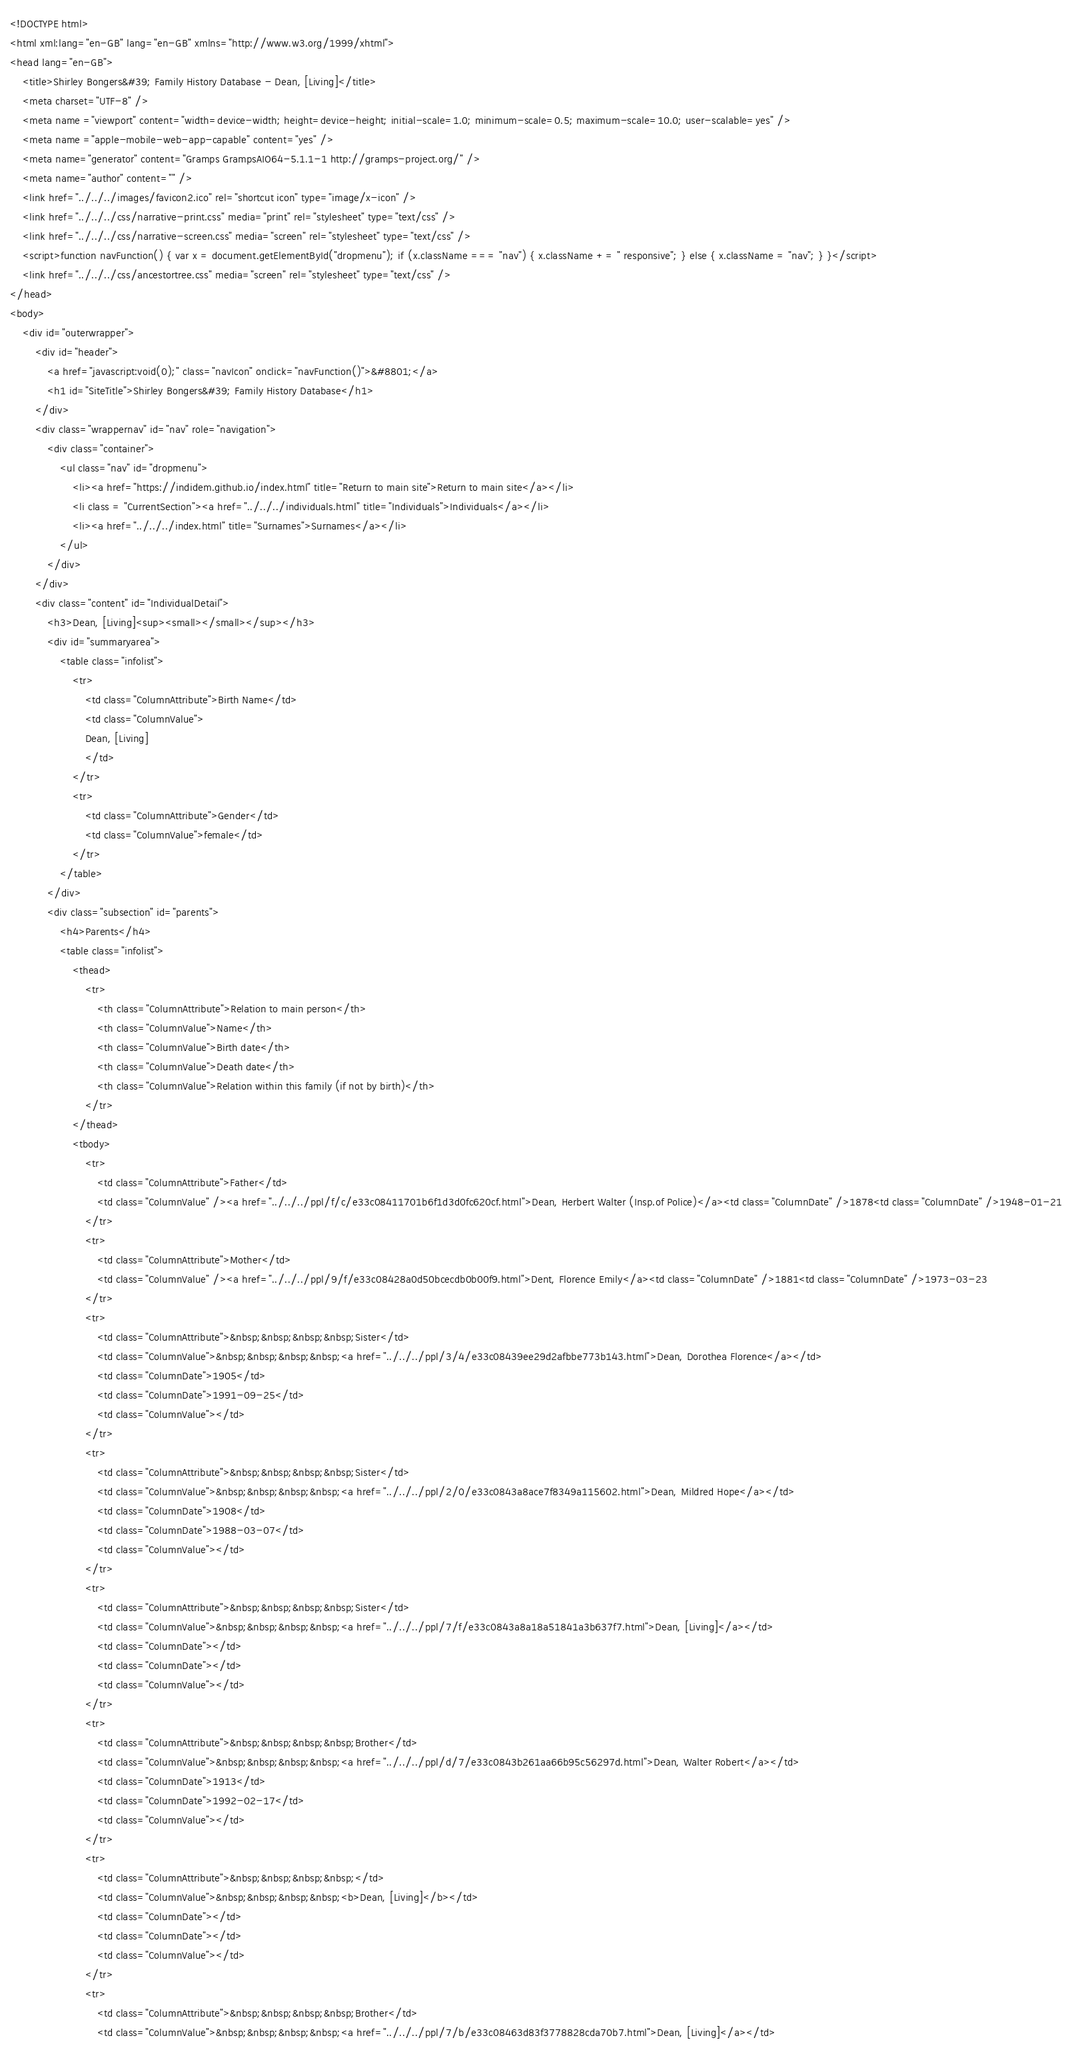Convert code to text. <code><loc_0><loc_0><loc_500><loc_500><_HTML_><!DOCTYPE html>
<html xml:lang="en-GB" lang="en-GB" xmlns="http://www.w3.org/1999/xhtml">
<head lang="en-GB">
	<title>Shirley Bongers&#39; Family History Database - Dean, [Living]</title>
	<meta charset="UTF-8" />
	<meta name ="viewport" content="width=device-width; height=device-height; initial-scale=1.0; minimum-scale=0.5; maximum-scale=10.0; user-scalable=yes" />
	<meta name ="apple-mobile-web-app-capable" content="yes" />
	<meta name="generator" content="Gramps GrampsAIO64-5.1.1-1 http://gramps-project.org/" />
	<meta name="author" content="" />
	<link href="../../../images/favicon2.ico" rel="shortcut icon" type="image/x-icon" />
	<link href="../../../css/narrative-print.css" media="print" rel="stylesheet" type="text/css" />
	<link href="../../../css/narrative-screen.css" media="screen" rel="stylesheet" type="text/css" />
	<script>function navFunction() { var x = document.getElementById("dropmenu"); if (x.className === "nav") { x.className += " responsive"; } else { x.className = "nav"; } }</script>
	<link href="../../../css/ancestortree.css" media="screen" rel="stylesheet" type="text/css" />
</head>
<body>
	<div id="outerwrapper">
		<div id="header">
			<a href="javascript:void(0);" class="navIcon" onclick="navFunction()">&#8801;</a>
			<h1 id="SiteTitle">Shirley Bongers&#39; Family History Database</h1>
		</div>
		<div class="wrappernav" id="nav" role="navigation">
			<div class="container">
				<ul class="nav" id="dropmenu">
					<li><a href="https://indidem.github.io/index.html" title="Return to main site">Return to main site</a></li>
					<li class = "CurrentSection"><a href="../../../individuals.html" title="Individuals">Individuals</a></li>
					<li><a href="../../../index.html" title="Surnames">Surnames</a></li>
				</ul>
			</div>
		</div>
		<div class="content" id="IndividualDetail">
			<h3>Dean, [Living]<sup><small></small></sup></h3>
			<div id="summaryarea">
				<table class="infolist">
					<tr>
						<td class="ColumnAttribute">Birth Name</td>
						<td class="ColumnValue">
						Dean, [Living]
						</td>
					</tr>
					<tr>
						<td class="ColumnAttribute">Gender</td>
						<td class="ColumnValue">female</td>
					</tr>
				</table>
			</div>
			<div class="subsection" id="parents">
				<h4>Parents</h4>
				<table class="infolist">
					<thead>
						<tr>
							<th class="ColumnAttribute">Relation to main person</th>
							<th class="ColumnValue">Name</th>
							<th class="ColumnValue">Birth date</th>
							<th class="ColumnValue">Death date</th>
							<th class="ColumnValue">Relation within this family (if not by birth)</th>
						</tr>
					</thead>
					<tbody>
						<tr>
							<td class="ColumnAttribute">Father</td>
							<td class="ColumnValue" /><a href="../../../ppl/f/c/e33c08411701b6f1d3d0fc620cf.html">Dean, Herbert Walter (Insp.of Police)</a><td class="ColumnDate" />1878<td class="ColumnDate" />1948-01-21
						</tr>
						<tr>
							<td class="ColumnAttribute">Mother</td>
							<td class="ColumnValue" /><a href="../../../ppl/9/f/e33c08428a0d50bcecdb0b00f9.html">Dent, Florence Emily</a><td class="ColumnDate" />1881<td class="ColumnDate" />1973-03-23
						</tr>
						<tr>
							<td class="ColumnAttribute">&nbsp;&nbsp;&nbsp;&nbsp;Sister</td>
							<td class="ColumnValue">&nbsp;&nbsp;&nbsp;&nbsp;<a href="../../../ppl/3/4/e33c08439ee29d2afbbe773b143.html">Dean, Dorothea Florence</a></td>
							<td class="ColumnDate">1905</td>
							<td class="ColumnDate">1991-09-25</td>
							<td class="ColumnValue"></td>
						</tr>
						<tr>
							<td class="ColumnAttribute">&nbsp;&nbsp;&nbsp;&nbsp;Sister</td>
							<td class="ColumnValue">&nbsp;&nbsp;&nbsp;&nbsp;<a href="../../../ppl/2/0/e33c0843a8ace7f8349a115602.html">Dean, Mildred Hope</a></td>
							<td class="ColumnDate">1908</td>
							<td class="ColumnDate">1988-03-07</td>
							<td class="ColumnValue"></td>
						</tr>
						<tr>
							<td class="ColumnAttribute">&nbsp;&nbsp;&nbsp;&nbsp;Sister</td>
							<td class="ColumnValue">&nbsp;&nbsp;&nbsp;&nbsp;<a href="../../../ppl/7/f/e33c0843a8a18a51841a3b637f7.html">Dean, [Living]</a></td>
							<td class="ColumnDate"></td>
							<td class="ColumnDate"></td>
							<td class="ColumnValue"></td>
						</tr>
						<tr>
							<td class="ColumnAttribute">&nbsp;&nbsp;&nbsp;&nbsp;Brother</td>
							<td class="ColumnValue">&nbsp;&nbsp;&nbsp;&nbsp;<a href="../../../ppl/d/7/e33c0843b261aa66b95c56297d.html">Dean, Walter Robert</a></td>
							<td class="ColumnDate">1913</td>
							<td class="ColumnDate">1992-02-17</td>
							<td class="ColumnValue"></td>
						</tr>
						<tr>
							<td class="ColumnAttribute">&nbsp;&nbsp;&nbsp;&nbsp;</td>
							<td class="ColumnValue">&nbsp;&nbsp;&nbsp;&nbsp;<b>Dean, [Living]</b></td>
							<td class="ColumnDate"></td>
							<td class="ColumnDate"></td>
							<td class="ColumnValue"></td>
						</tr>
						<tr>
							<td class="ColumnAttribute">&nbsp;&nbsp;&nbsp;&nbsp;Brother</td>
							<td class="ColumnValue">&nbsp;&nbsp;&nbsp;&nbsp;<a href="../../../ppl/7/b/e33c08463d83f3778828cda70b7.html">Dean, [Living]</a></td></code> 